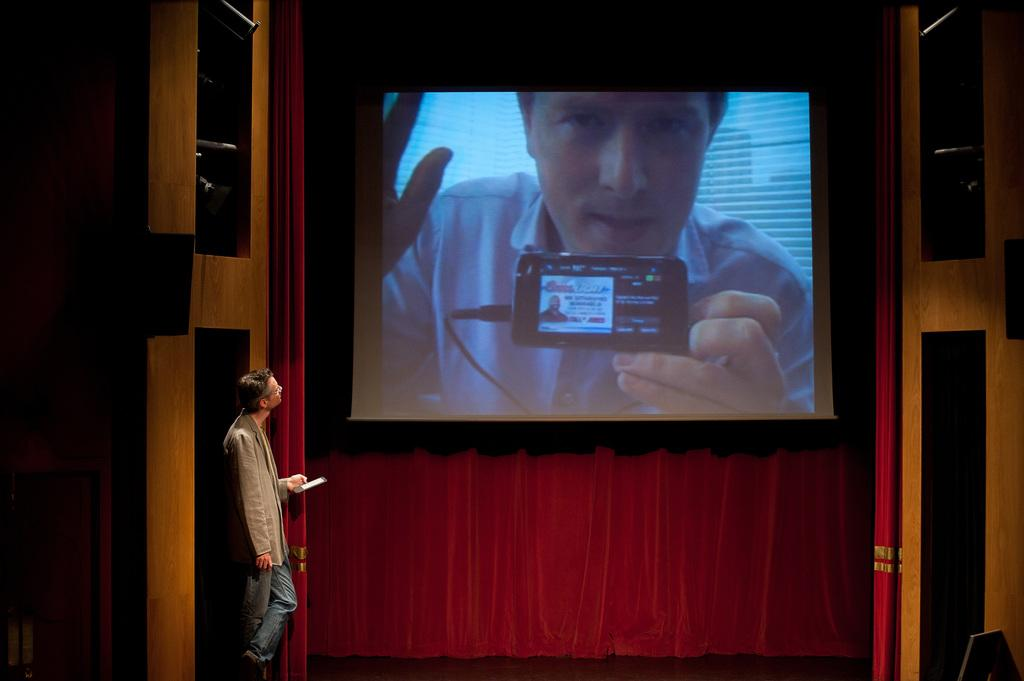Who is present in the image? There is a man in the image. What is the man holding in his hand? The man is holding a device in his hand. What can be seen on the device? There is a screen visible in the image. What type of setting is depicted in the image? The setting appears to be an auditorium. What color is the curtain in the image? There is a red curtain in the image. What type of process is the actor performing on stage in the image? There is no actor present in the image, and no process is being performed on stage. 